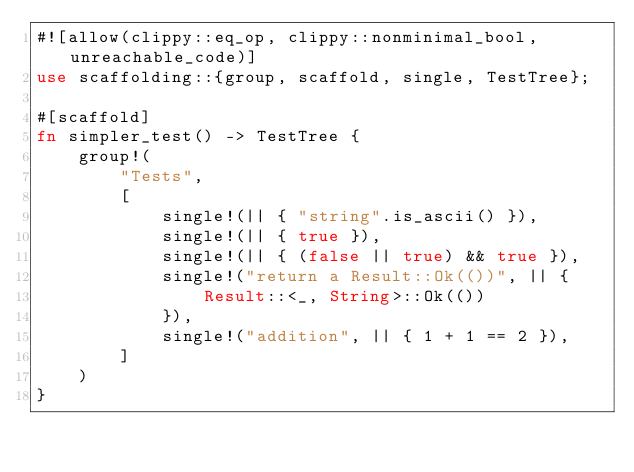Convert code to text. <code><loc_0><loc_0><loc_500><loc_500><_Rust_>#![allow(clippy::eq_op, clippy::nonminimal_bool, unreachable_code)]
use scaffolding::{group, scaffold, single, TestTree};

#[scaffold]
fn simpler_test() -> TestTree {
    group!(
        "Tests",
        [
            single!(|| { "string".is_ascii() }),
            single!(|| { true }),
            single!(|| { (false || true) && true }),
            single!("return a Result::Ok(())", || {
                Result::<_, String>::Ok(())
            }),
            single!("addition", || { 1 + 1 == 2 }),
        ]
    )
}
</code> 